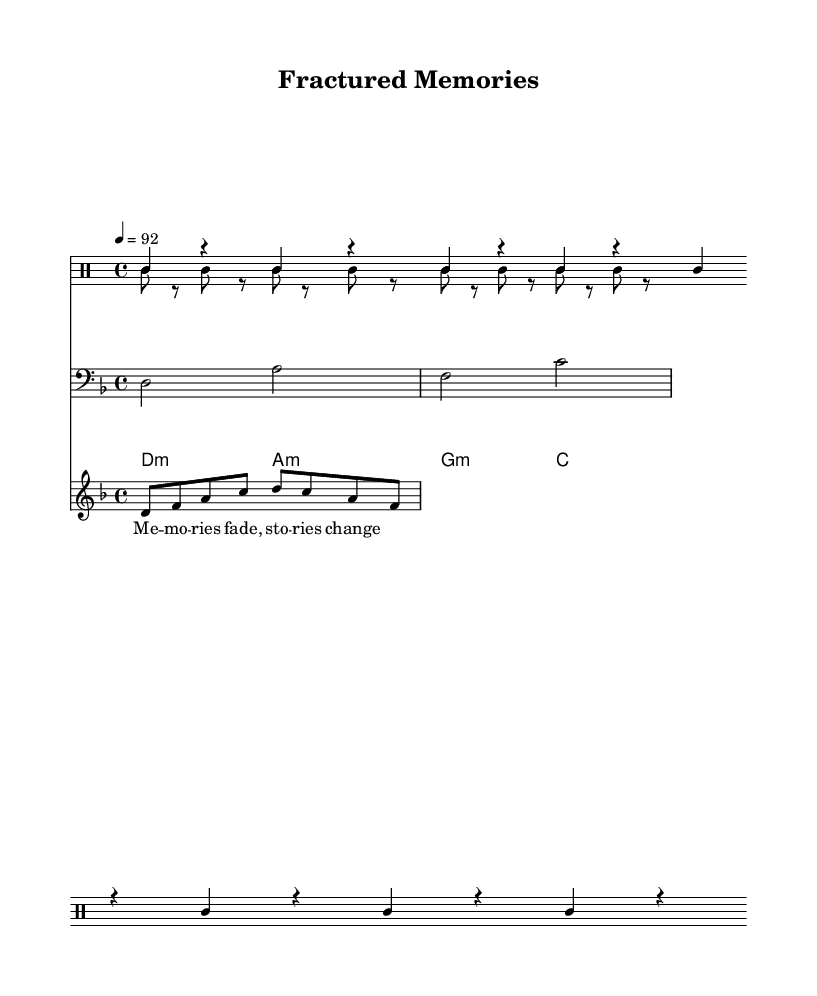What is the key signature of this music? The key signature is D minor, which is indicated by one flat (B flat) on the staff.
Answer: D minor What is the time signature of the piece? The time signature is 4/4, which is indicated at the beginning of the score.
Answer: 4/4 What is the tempo marking given for this piece? The tempo marking is indicated as 4 = 92, meaning there are 92 beats per minute for quarter notes.
Answer: 92 How many measures does the main beat repeat for? The main beat is indicated to repeat four times, as seen in the repeat marker.
Answer: 4 What does the lyric "Me -- mo -- ries fade, sto -- ries change" suggest about the theme? The lyrics suggest themes of memory and flux, indicating an unreliable narrator's shifting perspective or recollections.
Answer: Memory and flux What type of instruments are included in the score? The score includes a DrumStaff for percussion, a bass staff, and a melody staff, highlighting different instrumental sections typical for hip-hop tracks.
Answer: Drum, bass, melody What characterizes the structure typical of rap music in this piece? The use of repetitive beats combined with a melodic line reflects the structured, rhythmic nature of rap lyrics and music.
Answer: Repetitive beats and melody 